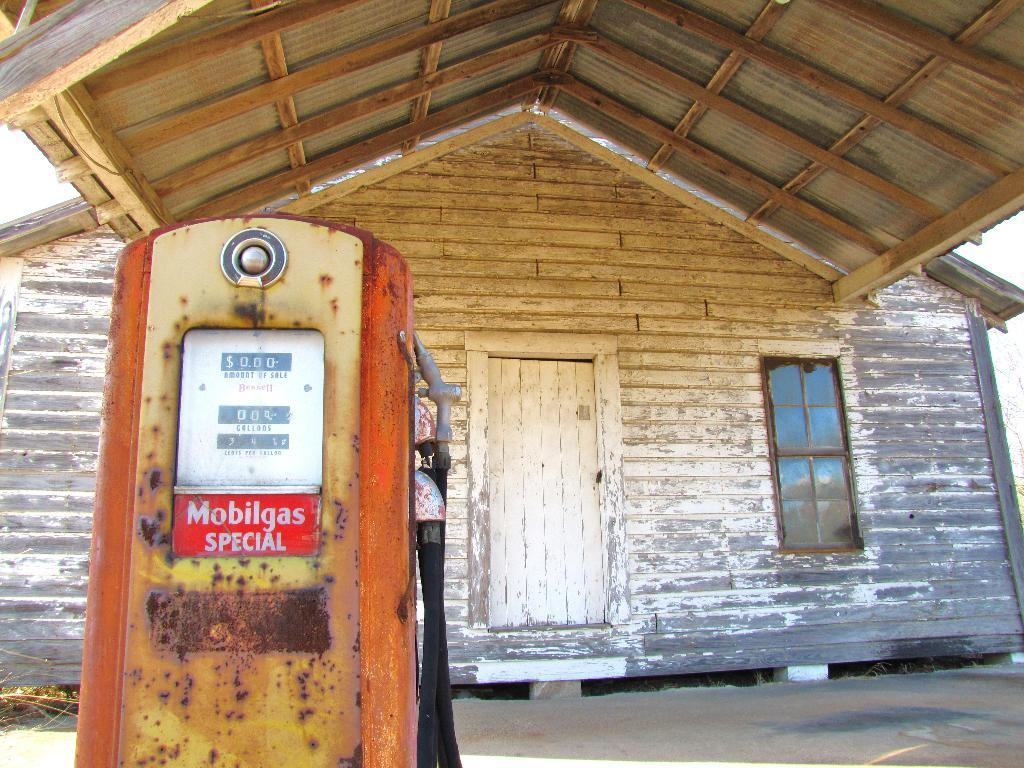What type of structure is present in the image? There is a house in the image. Can you describe a specific part of the house? There is a window in the house. What is the uppermost part of the house called? There is a roof on the house. How can one enter the house? There is a door in the house. What type of reaction can be seen from the deer in the image? There is no deer present in the image. Can you tell me how many fish are visible in the image? There are no fish visible in the image. 